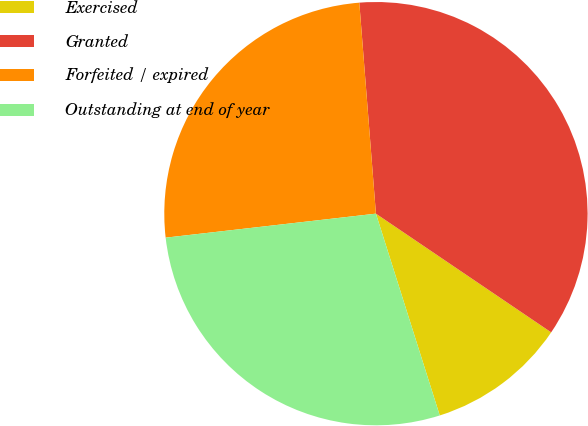Convert chart to OTSL. <chart><loc_0><loc_0><loc_500><loc_500><pie_chart><fcel>Exercised<fcel>Granted<fcel>Forfeited / expired<fcel>Outstanding at end of year<nl><fcel>10.65%<fcel>35.73%<fcel>25.56%<fcel>28.07%<nl></chart> 